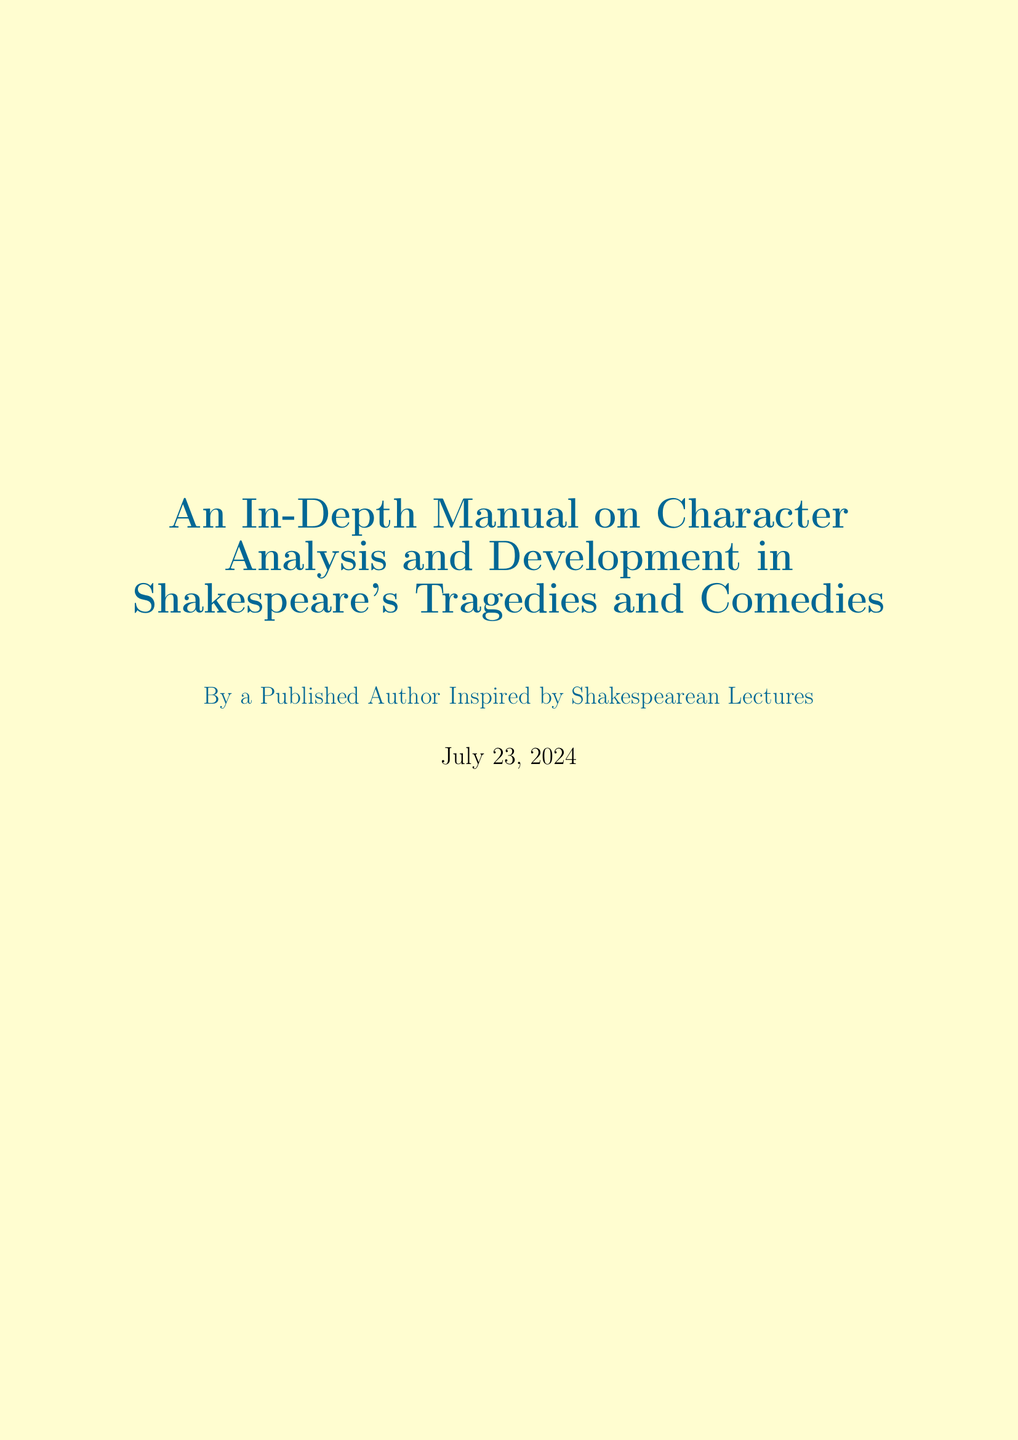What is the title of the manual? The title is explicitly stated at the beginning of the document.
Answer: An In-Depth Manual on Character Analysis and Development in Shakespeare's Tragedies and Comedies How many chapters are in the manual? The document includes a list of chapters that can be counted.
Answer: Ten Who is the author of the manual? The author is mentioned in the author note at the end of the document.
Answer: A Published Author Inspired by Shakespearean Lectures What character does the section on 'Jealousy and Manipulation' focus on? This section title directly indicates which character it pertains to.
Answer: Othello What is one technique mentioned for character development? The document lists techniques in a section that can be identified.
Answer: Soliloquies and Asides Which appendix contains templates for character maps? The appendix titles indicate the content within each one.
Answer: Appendix B: Character Map Templates What is the primary focus of the chapter 'Psychological Depth in Shakespeare's Characters'? This chapter title suggests its main topic.
Answer: Psychological complexity Which character is analyzed for 'Ambition and Moral Decay'? The document provides section titles that directly state the subject.
Answer: Macbeth What type of relationships are compared in the section titled 'Romantic Relationships in Comedies vs. Tragedies'? The section title indicates the contrasting relationship types discussed.
Answer: Comedies and Tragedies 